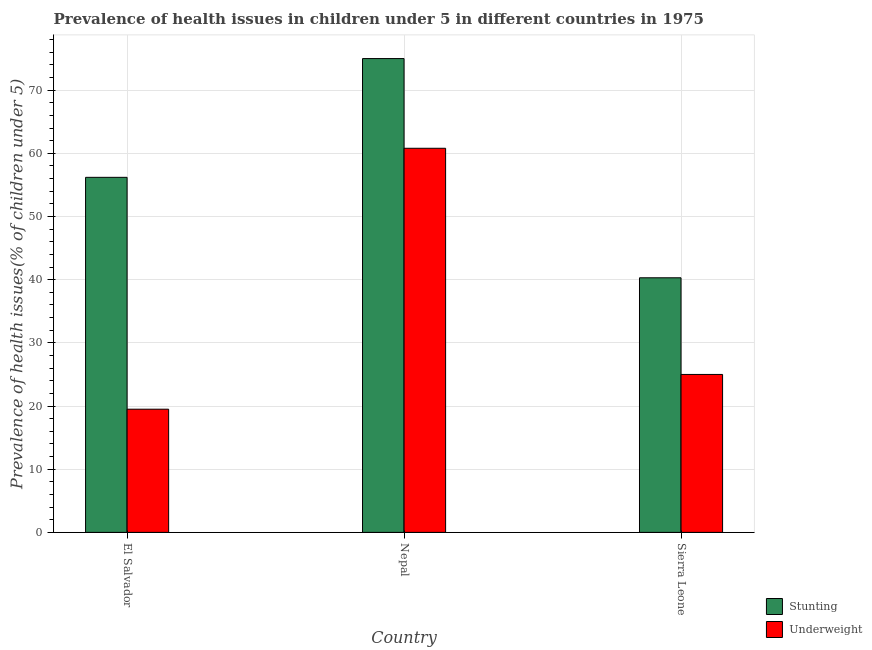Are the number of bars per tick equal to the number of legend labels?
Offer a terse response. Yes. Are the number of bars on each tick of the X-axis equal?
Offer a terse response. Yes. How many bars are there on the 1st tick from the right?
Ensure brevity in your answer.  2. What is the label of the 1st group of bars from the left?
Ensure brevity in your answer.  El Salvador. What is the percentage of stunted children in Nepal?
Make the answer very short. 75. Across all countries, what is the maximum percentage of stunted children?
Provide a succinct answer. 75. Across all countries, what is the minimum percentage of stunted children?
Keep it short and to the point. 40.3. In which country was the percentage of underweight children maximum?
Provide a short and direct response. Nepal. In which country was the percentage of underweight children minimum?
Offer a very short reply. El Salvador. What is the total percentage of underweight children in the graph?
Offer a terse response. 105.3. What is the difference between the percentage of underweight children in El Salvador and the percentage of stunted children in Nepal?
Keep it short and to the point. -55.5. What is the average percentage of stunted children per country?
Offer a terse response. 57.17. What is the difference between the percentage of underweight children and percentage of stunted children in El Salvador?
Your answer should be very brief. -36.7. What is the ratio of the percentage of underweight children in El Salvador to that in Sierra Leone?
Give a very brief answer. 0.78. What is the difference between the highest and the second highest percentage of underweight children?
Provide a short and direct response. 35.8. What is the difference between the highest and the lowest percentage of stunted children?
Ensure brevity in your answer.  34.7. Is the sum of the percentage of underweight children in Nepal and Sierra Leone greater than the maximum percentage of stunted children across all countries?
Your answer should be very brief. Yes. What does the 2nd bar from the left in Sierra Leone represents?
Your answer should be very brief. Underweight. What does the 2nd bar from the right in El Salvador represents?
Provide a succinct answer. Stunting. What is the difference between two consecutive major ticks on the Y-axis?
Provide a succinct answer. 10. Does the graph contain any zero values?
Give a very brief answer. No. Where does the legend appear in the graph?
Provide a short and direct response. Bottom right. How are the legend labels stacked?
Give a very brief answer. Vertical. What is the title of the graph?
Give a very brief answer. Prevalence of health issues in children under 5 in different countries in 1975. Does "Rural Population" appear as one of the legend labels in the graph?
Provide a short and direct response. No. What is the label or title of the X-axis?
Your response must be concise. Country. What is the label or title of the Y-axis?
Your response must be concise. Prevalence of health issues(% of children under 5). What is the Prevalence of health issues(% of children under 5) in Stunting in El Salvador?
Provide a succinct answer. 56.2. What is the Prevalence of health issues(% of children under 5) of Underweight in El Salvador?
Your answer should be very brief. 19.5. What is the Prevalence of health issues(% of children under 5) in Stunting in Nepal?
Ensure brevity in your answer.  75. What is the Prevalence of health issues(% of children under 5) in Underweight in Nepal?
Provide a succinct answer. 60.8. What is the Prevalence of health issues(% of children under 5) of Stunting in Sierra Leone?
Make the answer very short. 40.3. Across all countries, what is the maximum Prevalence of health issues(% of children under 5) of Underweight?
Offer a very short reply. 60.8. Across all countries, what is the minimum Prevalence of health issues(% of children under 5) in Stunting?
Your answer should be very brief. 40.3. What is the total Prevalence of health issues(% of children under 5) in Stunting in the graph?
Make the answer very short. 171.5. What is the total Prevalence of health issues(% of children under 5) in Underweight in the graph?
Ensure brevity in your answer.  105.3. What is the difference between the Prevalence of health issues(% of children under 5) in Stunting in El Salvador and that in Nepal?
Offer a very short reply. -18.8. What is the difference between the Prevalence of health issues(% of children under 5) of Underweight in El Salvador and that in Nepal?
Offer a very short reply. -41.3. What is the difference between the Prevalence of health issues(% of children under 5) in Underweight in El Salvador and that in Sierra Leone?
Ensure brevity in your answer.  -5.5. What is the difference between the Prevalence of health issues(% of children under 5) in Stunting in Nepal and that in Sierra Leone?
Give a very brief answer. 34.7. What is the difference between the Prevalence of health issues(% of children under 5) of Underweight in Nepal and that in Sierra Leone?
Give a very brief answer. 35.8. What is the difference between the Prevalence of health issues(% of children under 5) in Stunting in El Salvador and the Prevalence of health issues(% of children under 5) in Underweight in Nepal?
Provide a short and direct response. -4.6. What is the difference between the Prevalence of health issues(% of children under 5) in Stunting in El Salvador and the Prevalence of health issues(% of children under 5) in Underweight in Sierra Leone?
Your answer should be compact. 31.2. What is the average Prevalence of health issues(% of children under 5) in Stunting per country?
Make the answer very short. 57.17. What is the average Prevalence of health issues(% of children under 5) in Underweight per country?
Provide a short and direct response. 35.1. What is the difference between the Prevalence of health issues(% of children under 5) of Stunting and Prevalence of health issues(% of children under 5) of Underweight in El Salvador?
Make the answer very short. 36.7. What is the difference between the Prevalence of health issues(% of children under 5) in Stunting and Prevalence of health issues(% of children under 5) in Underweight in Sierra Leone?
Make the answer very short. 15.3. What is the ratio of the Prevalence of health issues(% of children under 5) of Stunting in El Salvador to that in Nepal?
Your response must be concise. 0.75. What is the ratio of the Prevalence of health issues(% of children under 5) of Underweight in El Salvador to that in Nepal?
Provide a succinct answer. 0.32. What is the ratio of the Prevalence of health issues(% of children under 5) in Stunting in El Salvador to that in Sierra Leone?
Ensure brevity in your answer.  1.39. What is the ratio of the Prevalence of health issues(% of children under 5) in Underweight in El Salvador to that in Sierra Leone?
Your answer should be very brief. 0.78. What is the ratio of the Prevalence of health issues(% of children under 5) in Stunting in Nepal to that in Sierra Leone?
Your answer should be very brief. 1.86. What is the ratio of the Prevalence of health issues(% of children under 5) of Underweight in Nepal to that in Sierra Leone?
Make the answer very short. 2.43. What is the difference between the highest and the second highest Prevalence of health issues(% of children under 5) in Stunting?
Offer a terse response. 18.8. What is the difference between the highest and the second highest Prevalence of health issues(% of children under 5) of Underweight?
Make the answer very short. 35.8. What is the difference between the highest and the lowest Prevalence of health issues(% of children under 5) of Stunting?
Give a very brief answer. 34.7. What is the difference between the highest and the lowest Prevalence of health issues(% of children under 5) in Underweight?
Ensure brevity in your answer.  41.3. 